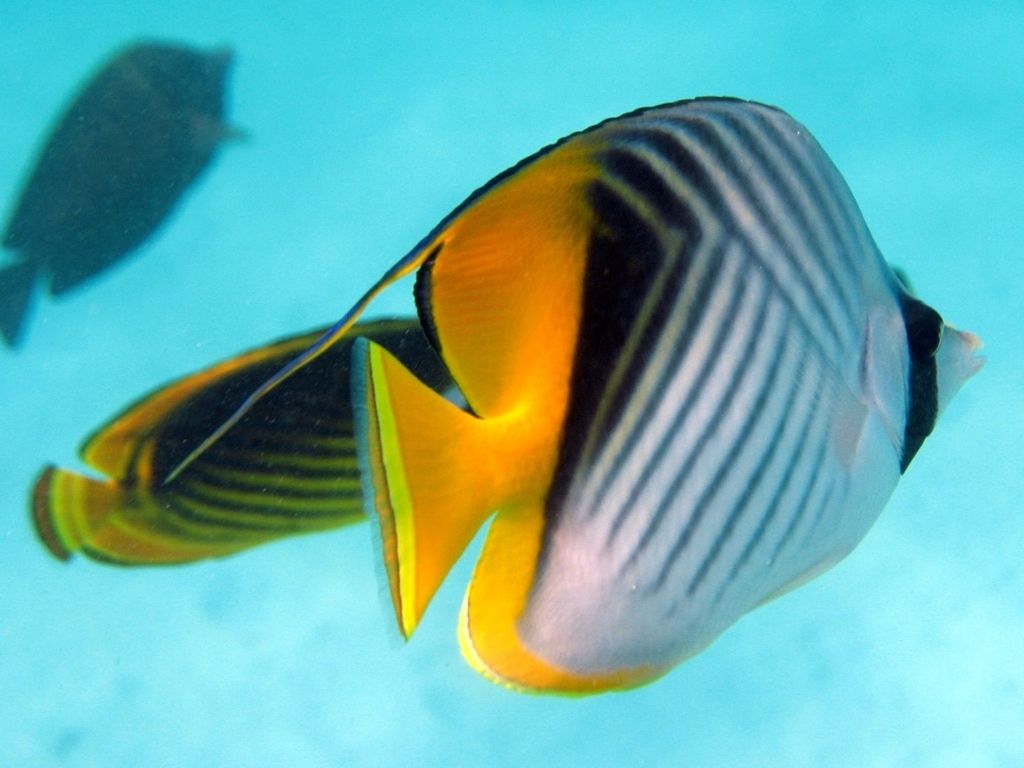Can you explain the characteristics of the marine environment depicted in this image? The marine environment in this image is characteristic of a coral reef, discernible by the clear, turquoise water often found in such habitats. The absence of other competing elements suggests a relatively unpolluted area, often necessary for coral reefs to thrive. The lighting is strong and likely indicates a shallow depth, which is where reef fish like the one pictured are typically found, taking advantage of the sunlight and the rich biodiversity that coral ecosystems support. 